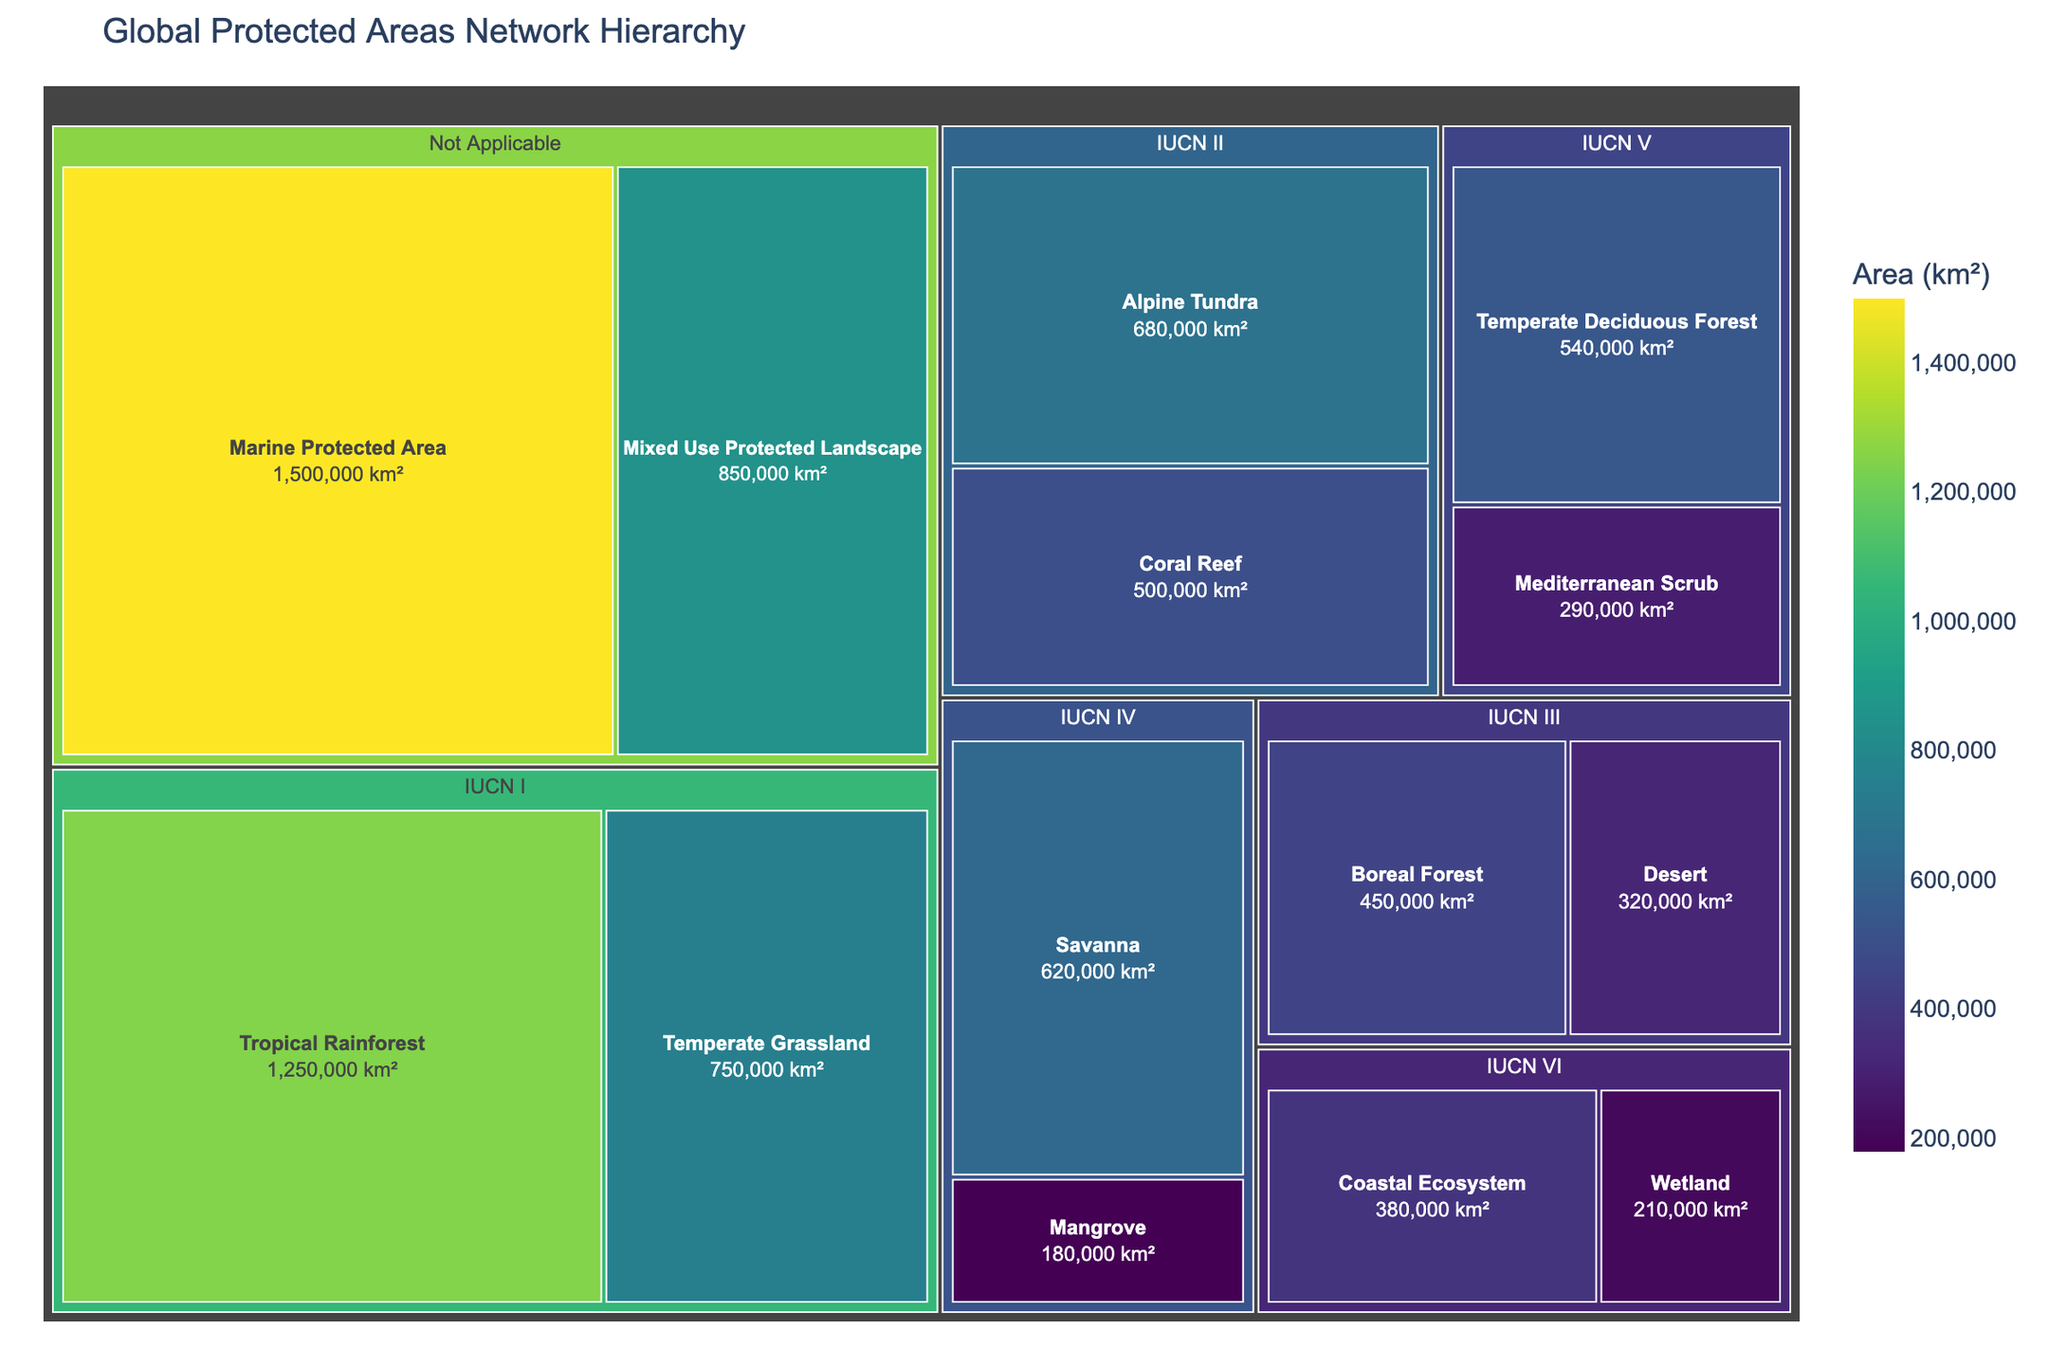What is the largest ecosystem area in the "IUCN I" category? The "IUCN I" category contains two ecosystems: Tropical Rainforest and Temperate Grassland. The area of Tropical Rainforest is 1,250,000 km², and the area of Temperate Grassland is 750,000 km². The larger area is Tropic Rainforest.
Answer: Tropical Rainforest What is the total area of ecosystems in the "IUCN II" category? In the "IUCN II" category, the Coral Reef has an area of 500,000 km², and Alpine Tundra has 680,000 km². The total area is 500,000 + 680,000 = 1,180,000 km².
Answer: 1,180,000 km² Which category has a larger total protected area: "IUCN III" or "IUCN IV"? "IUCN III" has Desert and Boreal Forest with areas 320,000 km² and 450,000 km², respectively. The total area is 320,000 + 450,000 = 770,000 km². "IUCN IV" has Mangrove and Savanna with areas 180,000 km² and 620,000 km², respectively. The total area is 180,000 + 620,000 = 800,000 km². Since 800,000 km² is greater than 770,000 km², "IUCN IV" has a larger total area.
Answer: IUCN IV What proportion of the "Not Applicable" category is contributed by Marine Protected Area? The "Not Applicable" category consists of Marine Protected Area (1,500,000 km²) and Mixed Use Protected Landscape (850,000 km²). The total area of this category is 1,500,000 + 850,000 = 2,350,000 km². The proportion contributed by Marine Protected Area is (1,500,000 / 2,350,000) * 100 = 63.83%.
Answer: 63.83% What is the average area size of ecosystems in the "IUCN V" category? "IUCN V" contains Mediterranean Scrub (290,000 km²) and Temperate Deciduous Forest (540,000 km²). The average area is (290,000 + 540,000) / 2 = 415,000 km².
Answer: 415,000 km² What is the smallest ecosystem in the "IUCN VI" category? The "IUCN VI" category contains Wetland (210,000 km²) and Coastal Ecosystem (380,000 km²). The smaller of the two is Wetland.
Answer: Wetland How many distinct ecosystem types are depicted in the plot? The plot portrays the following ecosystems: Tropical Rainforest, Temperate Grassland, Coral Reef, Alpine Tundra, Desert, Boreal Forest, Mangrove, Savanna, Mediterranean Scrub, Temperate Deciduous Forest, Wetland, Coastal Ecosystem, Marine Protected Area, and Mixed Use Protected Landscape. There are 14 distinct ecosystem types.
Answer: 14 What is the total area of all ecosystems combined? Adding the areas of all ecosystems: 1,250,000 + 750,000 + 500,000 + 680,000 + 320,000 + 450,000 + 180,000 + 620,000 + 290,000 + 540,000 + 210,000 + 380,000 + 1,500,000 + 850,000 = 8,520,000 km².
Answer: 8,520,000 km² 